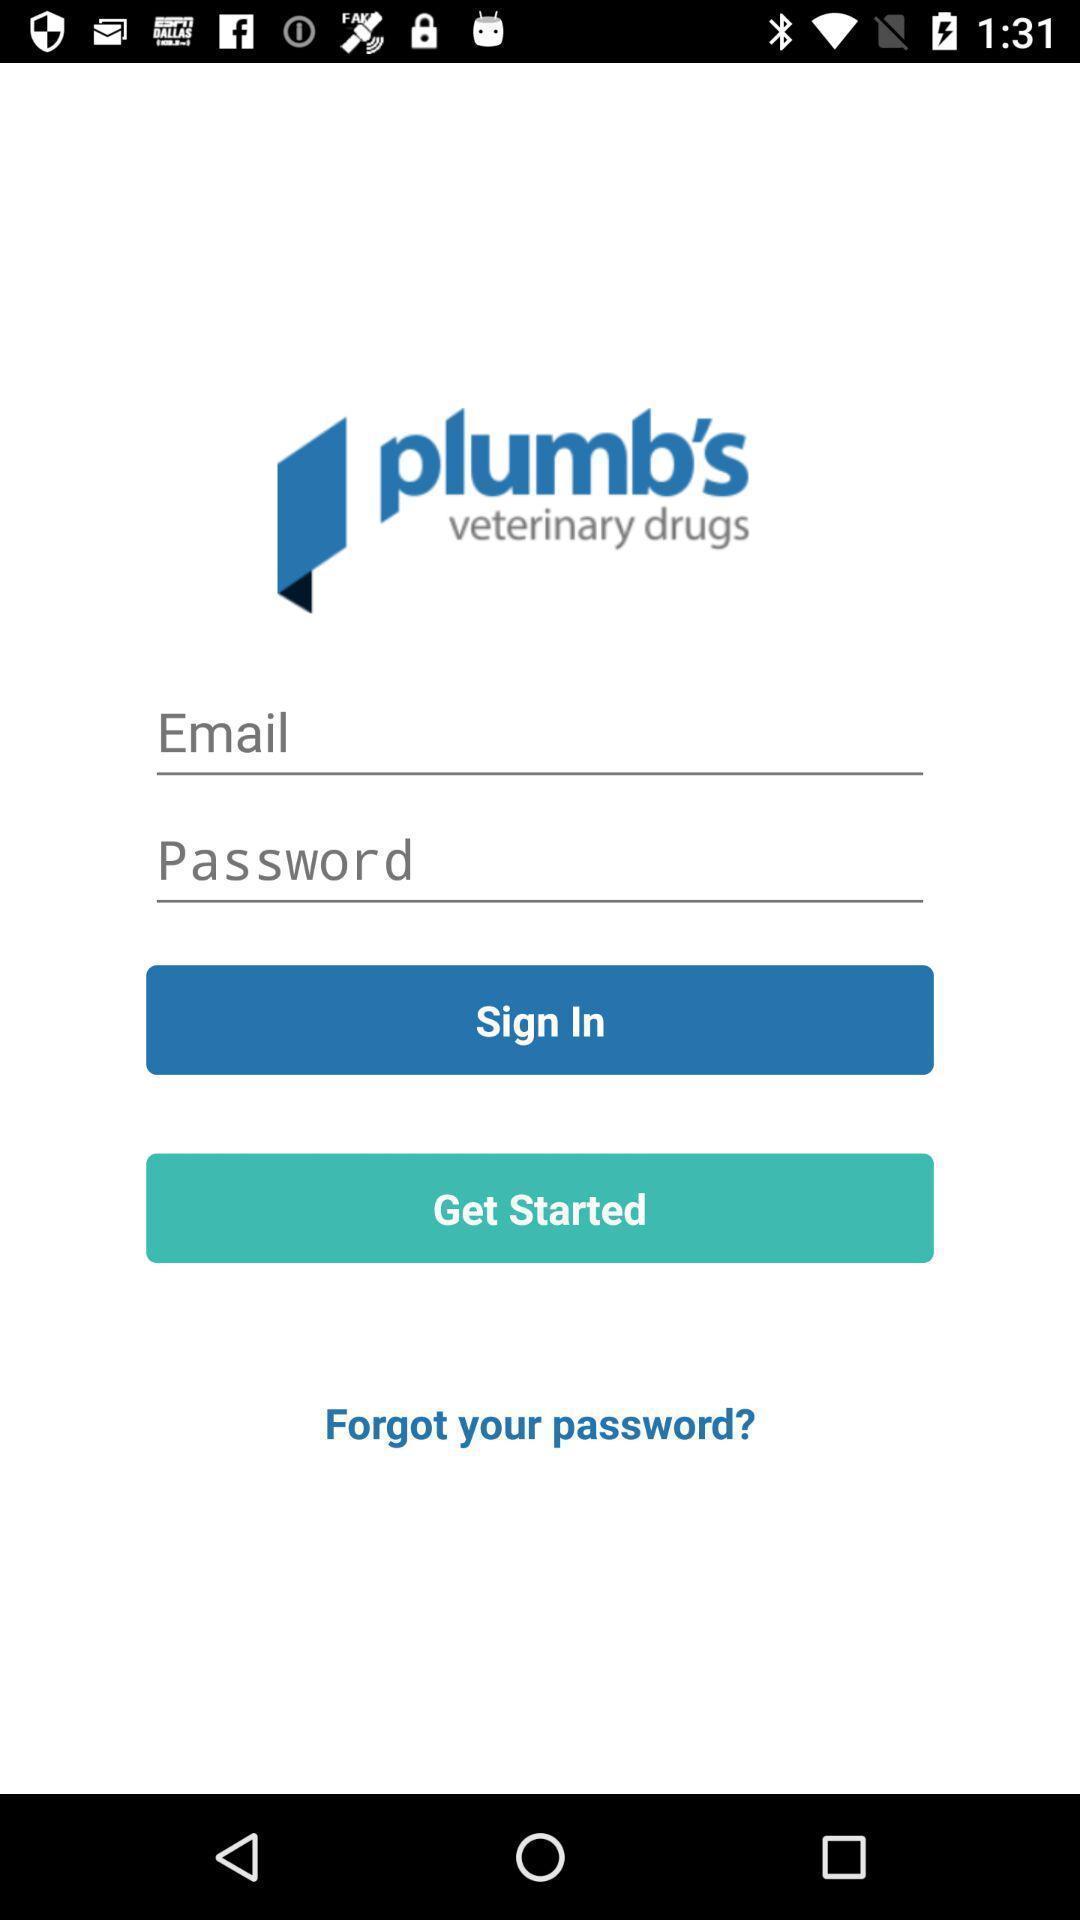Explain what's happening in this screen capture. Sign-in page of a drug information app. 